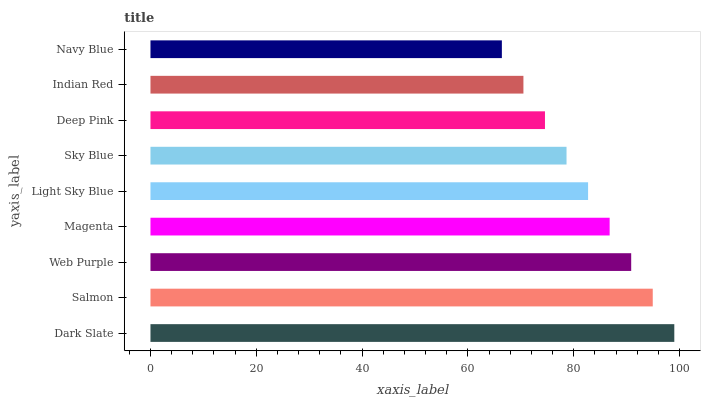Is Navy Blue the minimum?
Answer yes or no. Yes. Is Dark Slate the maximum?
Answer yes or no. Yes. Is Salmon the minimum?
Answer yes or no. No. Is Salmon the maximum?
Answer yes or no. No. Is Dark Slate greater than Salmon?
Answer yes or no. Yes. Is Salmon less than Dark Slate?
Answer yes or no. Yes. Is Salmon greater than Dark Slate?
Answer yes or no. No. Is Dark Slate less than Salmon?
Answer yes or no. No. Is Light Sky Blue the high median?
Answer yes or no. Yes. Is Light Sky Blue the low median?
Answer yes or no. Yes. Is Deep Pink the high median?
Answer yes or no. No. Is Dark Slate the low median?
Answer yes or no. No. 